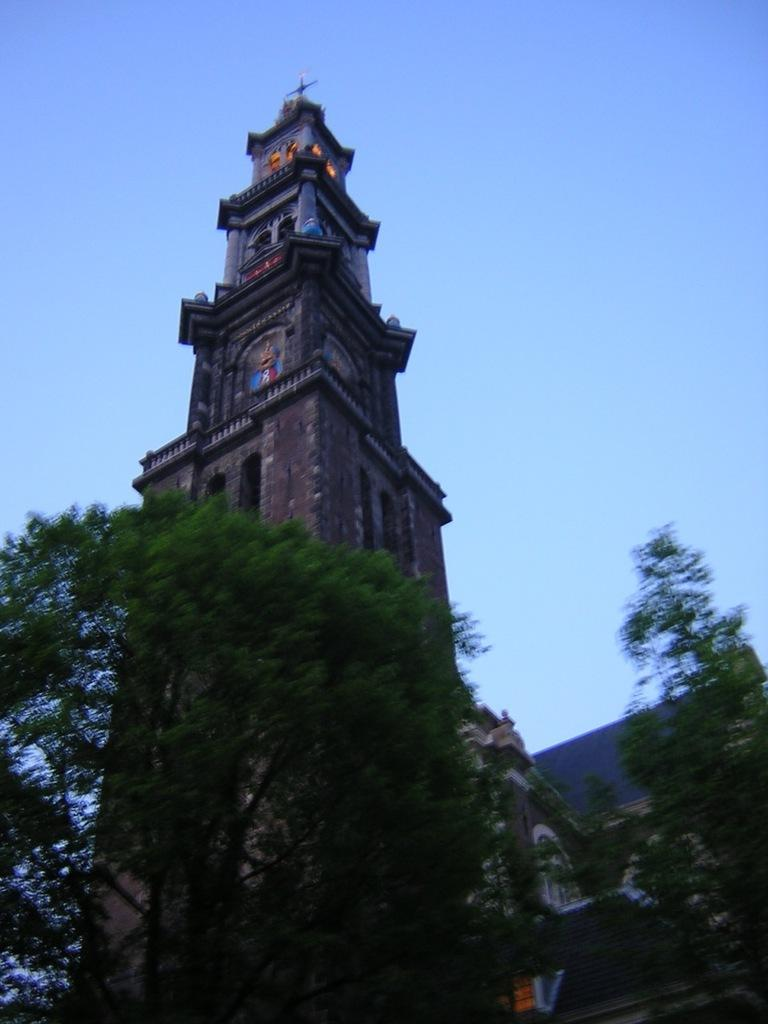What type of structure is present in the image? There is a building in the image. What feature can be seen on the building? The building has windows. What else can be seen in the image besides the building? Trees and the sky are visible in the image. How would you describe the sky in the image? The sky appears to be cloudy in the image. How many chairs are placed around the building in the image? There are no chairs visible in the image; it only features a building, trees, and the sky. What riddle can be solved by looking at the image? There is no riddle present in the image; it simply shows a building, trees, and the sky. 